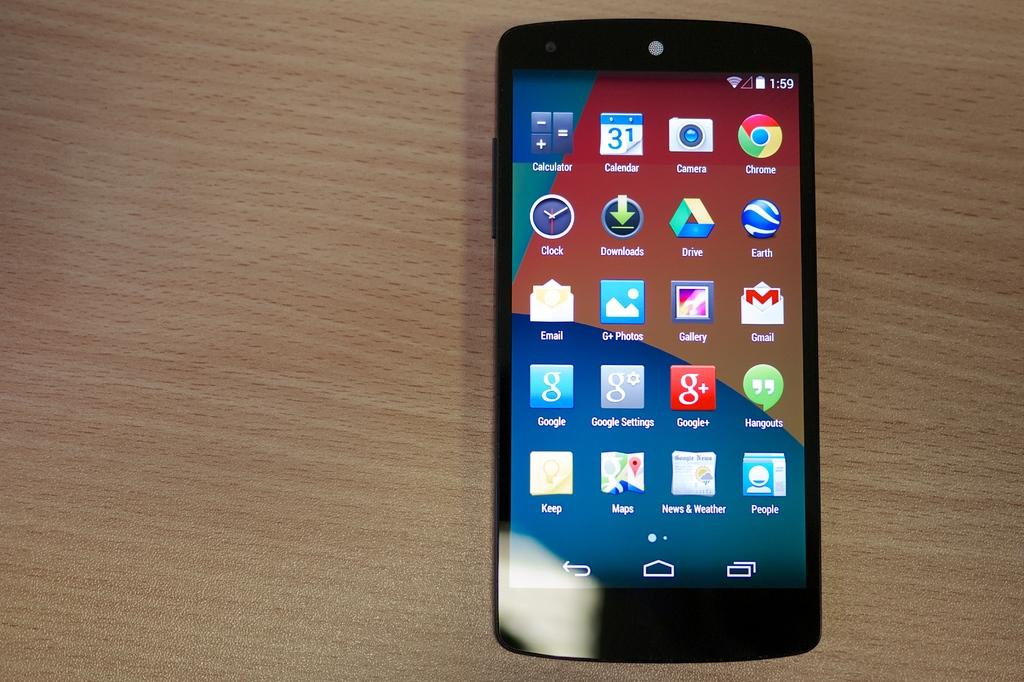<image>
Describe the image concisely. The top row of icons on a cell phone screen are calculator, calendar, camera and Chrome. 